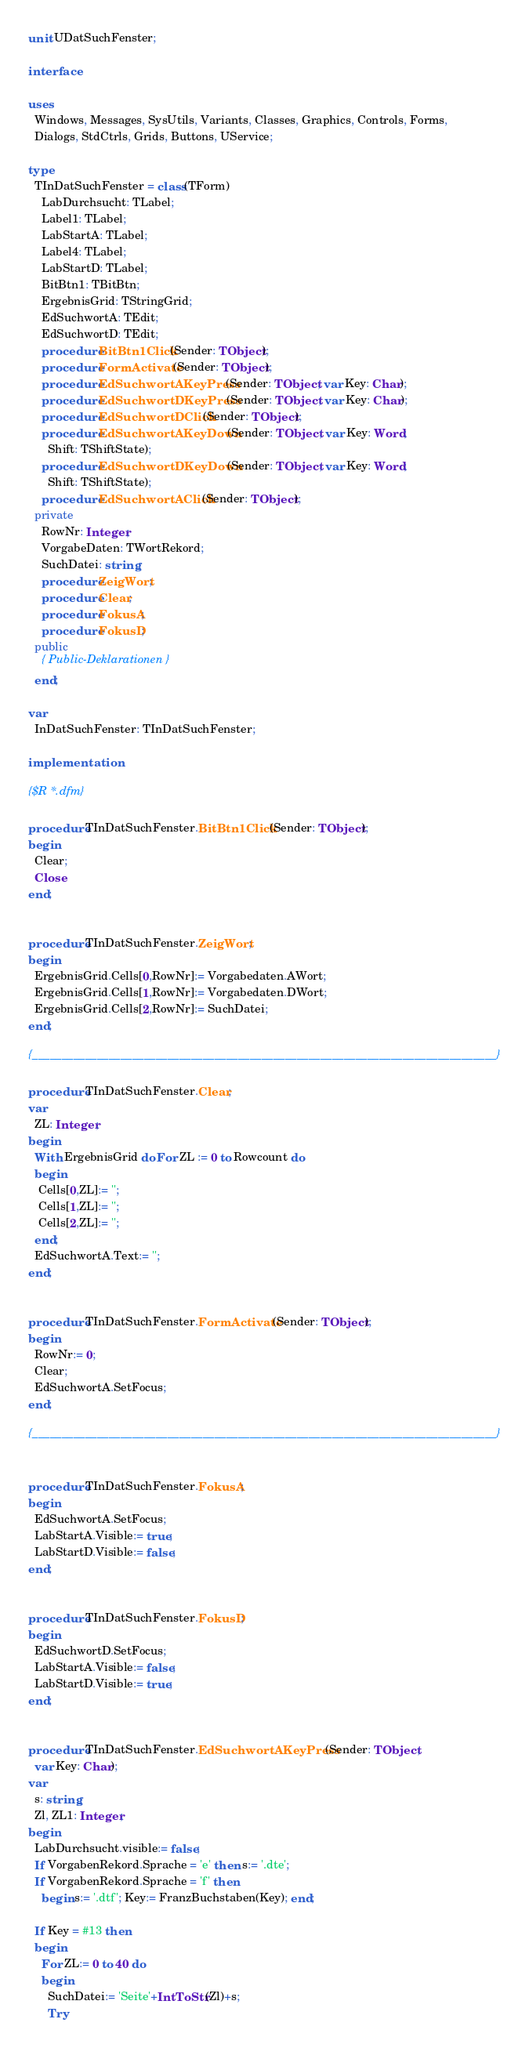Convert code to text. <code><loc_0><loc_0><loc_500><loc_500><_Pascal_>unit UDatSuchFenster;

interface

uses
  Windows, Messages, SysUtils, Variants, Classes, Graphics, Controls, Forms,
  Dialogs, StdCtrls, Grids, Buttons, UService;

type
  TInDatSuchFenster = class(TForm)
    LabDurchsucht: TLabel;
    Label1: TLabel;
    LabStartA: TLabel;
    Label4: TLabel;
    LabStartD: TLabel;
    BitBtn1: TBitBtn;
    ErgebnisGrid: TStringGrid;
    EdSuchwortA: TEdit;
    EdSuchwortD: TEdit;
    procedure BitBtn1Click(Sender: TObject);
    procedure FormActivate(Sender: TObject);
    procedure EdSuchwortAKeyPress(Sender: TObject; var Key: Char);
    procedure EdSuchwortDKeyPress(Sender: TObject; var Key: Char);
    procedure EdSuchwortDClick(Sender: TObject);
    procedure EdSuchwortAKeyDown(Sender: TObject; var Key: Word;
      Shift: TShiftState);
    procedure EdSuchwortDKeyDown(Sender: TObject; var Key: Word;
      Shift: TShiftState);
    procedure EdSuchwortAClick(Sender: TObject);
  private
    RowNr: Integer;
    VorgabeDaten: TWortRekord;
    SuchDatei: string;
    procedure ZeigWort;
    procedure Clear;
    procedure FokusA;
    procedure FokusD;
  public
    { Public-Deklarationen }
  end;

var
  InDatSuchFenster: TInDatSuchFenster;

implementation

{$R *.dfm}

procedure TInDatSuchFenster.BitBtn1Click(Sender: TObject);
begin
  Clear;
  Close
end;


procedure TInDatSuchFenster.ZeigWort;
begin
  ErgebnisGrid.Cells[0,RowNr]:= Vorgabedaten.AWort;
  ErgebnisGrid.Cells[1,RowNr]:= Vorgabedaten.DWort;
  ErgebnisGrid.Cells[2,RowNr]:= SuchDatei;
end;

{_______________________________________________________________________________}

procedure TInDatSuchFenster.Clear;
var
  ZL: Integer;
begin
  With ErgebnisGrid do For ZL := 0 to Rowcount do
  begin
   Cells[0,ZL]:= '';
   Cells[1,ZL]:= '';
   Cells[2,ZL]:= '';
  end;
  EdSuchwortA.Text:= '';
end;


procedure TInDatSuchFenster.FormActivate(Sender: TObject);
begin
  RowNr:= 0;
  Clear;
  EdSuchwortA.SetFocus;
end;

{_______________________________________________________________________________}


procedure TInDatSuchFenster.FokusA;
begin
  EdSuchwortA.SetFocus;
  LabStartA.Visible:= true;
  LabStartD.Visible:= false;
end;


procedure TInDatSuchFenster.FokusD;
begin
  EdSuchwortD.SetFocus;
  LabStartA.Visible:= false;
  LabStartD.Visible:= true;
end;


procedure TInDatSuchFenster.EdSuchwortAKeyPress(Sender: TObject;
  var Key: Char);
var
  s: string;
  Zl, ZL1: Integer;
begin
  LabDurchsucht.visible:= false;
  If VorgabenRekord.Sprache = 'e' then s:= '.dte';
  If VorgabenRekord.Sprache = 'f' then
    begin s:= '.dtf'; Key:= FranzBuchstaben(Key); end;

  If Key = #13 then
  begin
    For ZL:= 0 to 40 do
    begin
      SuchDatei:= 'Seite'+IntToStr(Zl)+s;
      Try</code> 